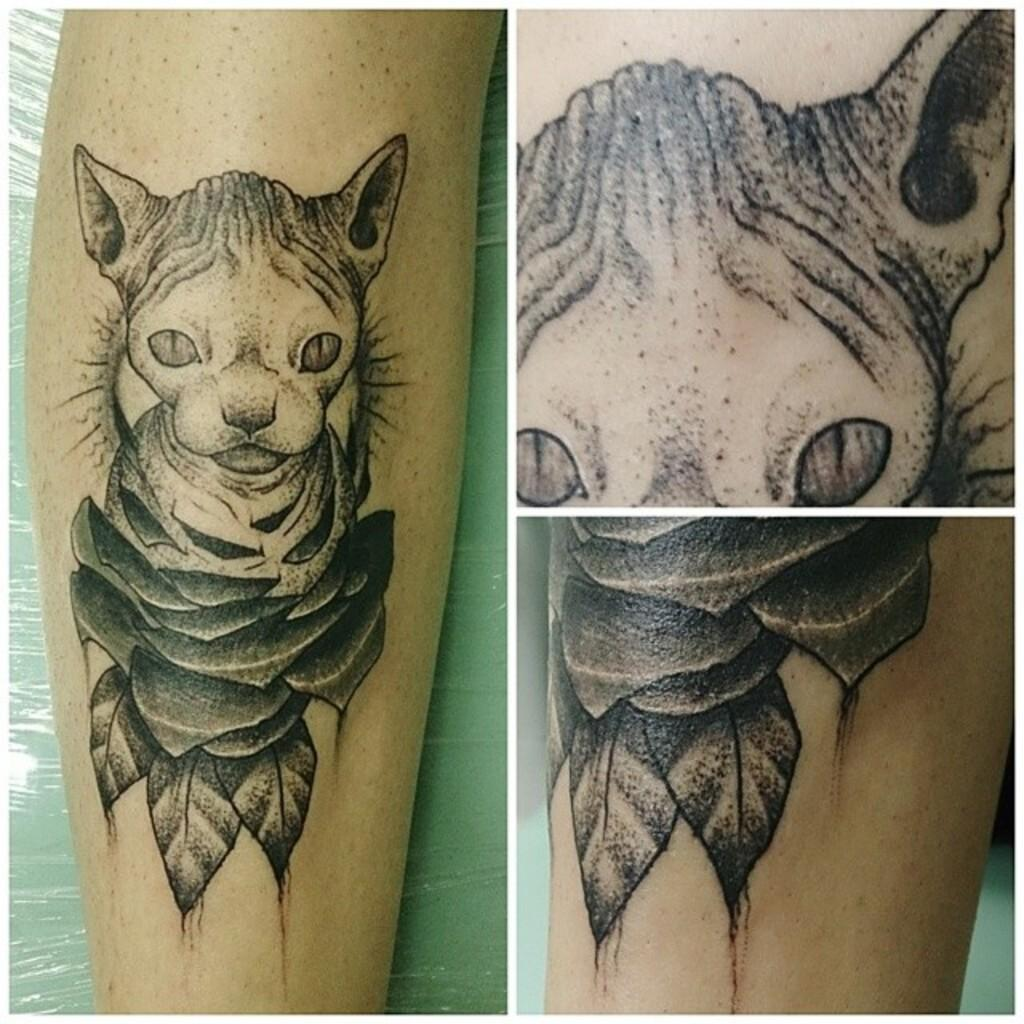What part of a person can be seen in the image? There is a person's hand visible in the image. What type of image is the hand part of? The image is a collage. What additional feature can be seen on the person's hand? There is a tattoo on the person's hand. How many pigs are visible in the image? There are no pigs present in the image; it features a person's hand with a tattoo in a collage. 